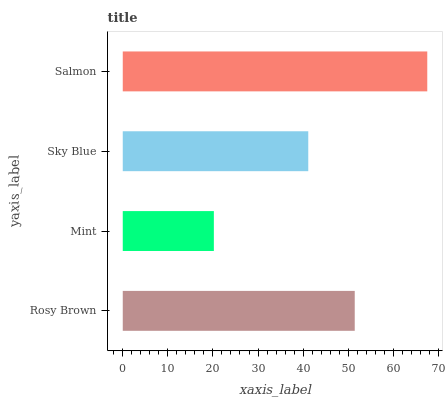Is Mint the minimum?
Answer yes or no. Yes. Is Salmon the maximum?
Answer yes or no. Yes. Is Sky Blue the minimum?
Answer yes or no. No. Is Sky Blue the maximum?
Answer yes or no. No. Is Sky Blue greater than Mint?
Answer yes or no. Yes. Is Mint less than Sky Blue?
Answer yes or no. Yes. Is Mint greater than Sky Blue?
Answer yes or no. No. Is Sky Blue less than Mint?
Answer yes or no. No. Is Rosy Brown the high median?
Answer yes or no. Yes. Is Sky Blue the low median?
Answer yes or no. Yes. Is Sky Blue the high median?
Answer yes or no. No. Is Rosy Brown the low median?
Answer yes or no. No. 